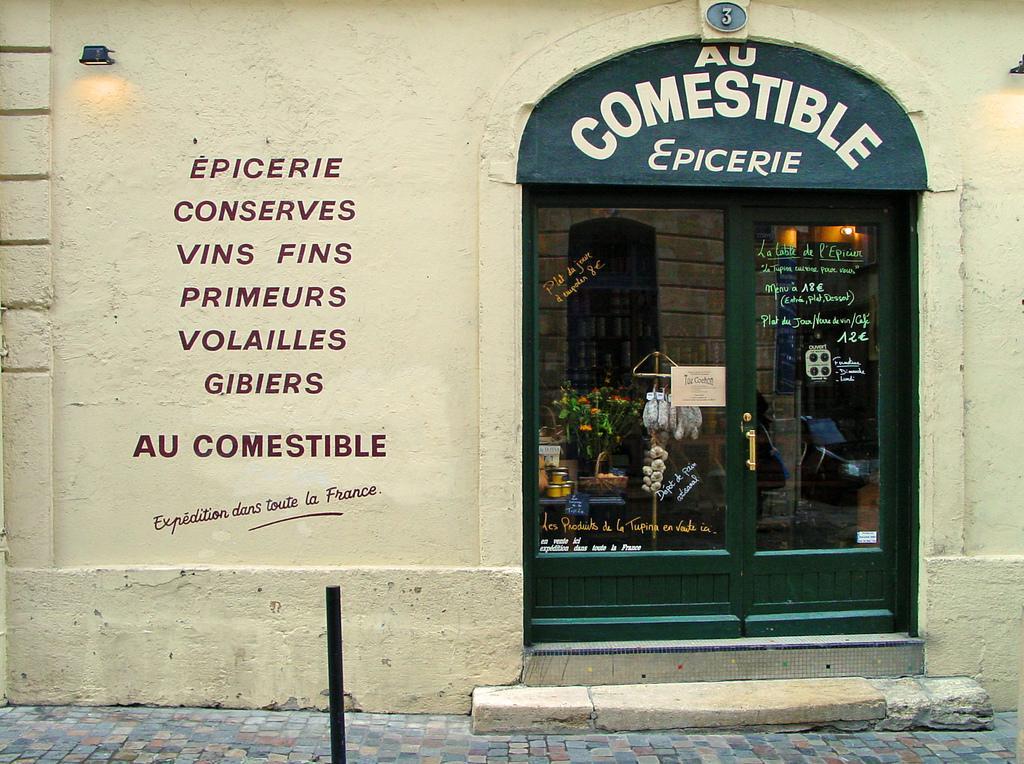How would you summarize this image in a sentence or two? In this image there is a building with some text on the wall and there is a glass door, the top of the door there is some text. In front of the building there is a rod on the path. 